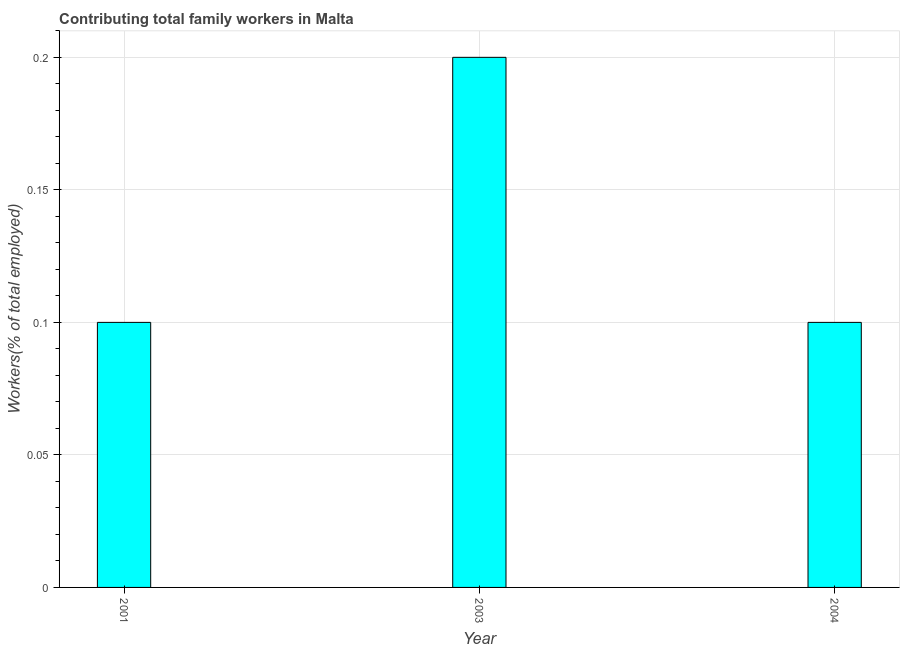Does the graph contain any zero values?
Give a very brief answer. No. What is the title of the graph?
Ensure brevity in your answer.  Contributing total family workers in Malta. What is the label or title of the Y-axis?
Your answer should be compact. Workers(% of total employed). What is the contributing family workers in 2004?
Your response must be concise. 0.1. Across all years, what is the maximum contributing family workers?
Offer a very short reply. 0.2. Across all years, what is the minimum contributing family workers?
Keep it short and to the point. 0.1. What is the sum of the contributing family workers?
Your answer should be compact. 0.4. What is the average contributing family workers per year?
Make the answer very short. 0.13. What is the median contributing family workers?
Ensure brevity in your answer.  0.1. What is the difference between the highest and the second highest contributing family workers?
Provide a succinct answer. 0.1. Is the sum of the contributing family workers in 2001 and 2003 greater than the maximum contributing family workers across all years?
Your answer should be very brief. Yes. In how many years, is the contributing family workers greater than the average contributing family workers taken over all years?
Keep it short and to the point. 1. How many bars are there?
Ensure brevity in your answer.  3. Are all the bars in the graph horizontal?
Provide a succinct answer. No. How many years are there in the graph?
Give a very brief answer. 3. Are the values on the major ticks of Y-axis written in scientific E-notation?
Provide a short and direct response. No. What is the Workers(% of total employed) in 2001?
Keep it short and to the point. 0.1. What is the Workers(% of total employed) in 2003?
Your response must be concise. 0.2. What is the Workers(% of total employed) of 2004?
Offer a terse response. 0.1. What is the difference between the Workers(% of total employed) in 2001 and 2003?
Offer a terse response. -0.1. What is the ratio of the Workers(% of total employed) in 2001 to that in 2003?
Your answer should be very brief. 0.5. 